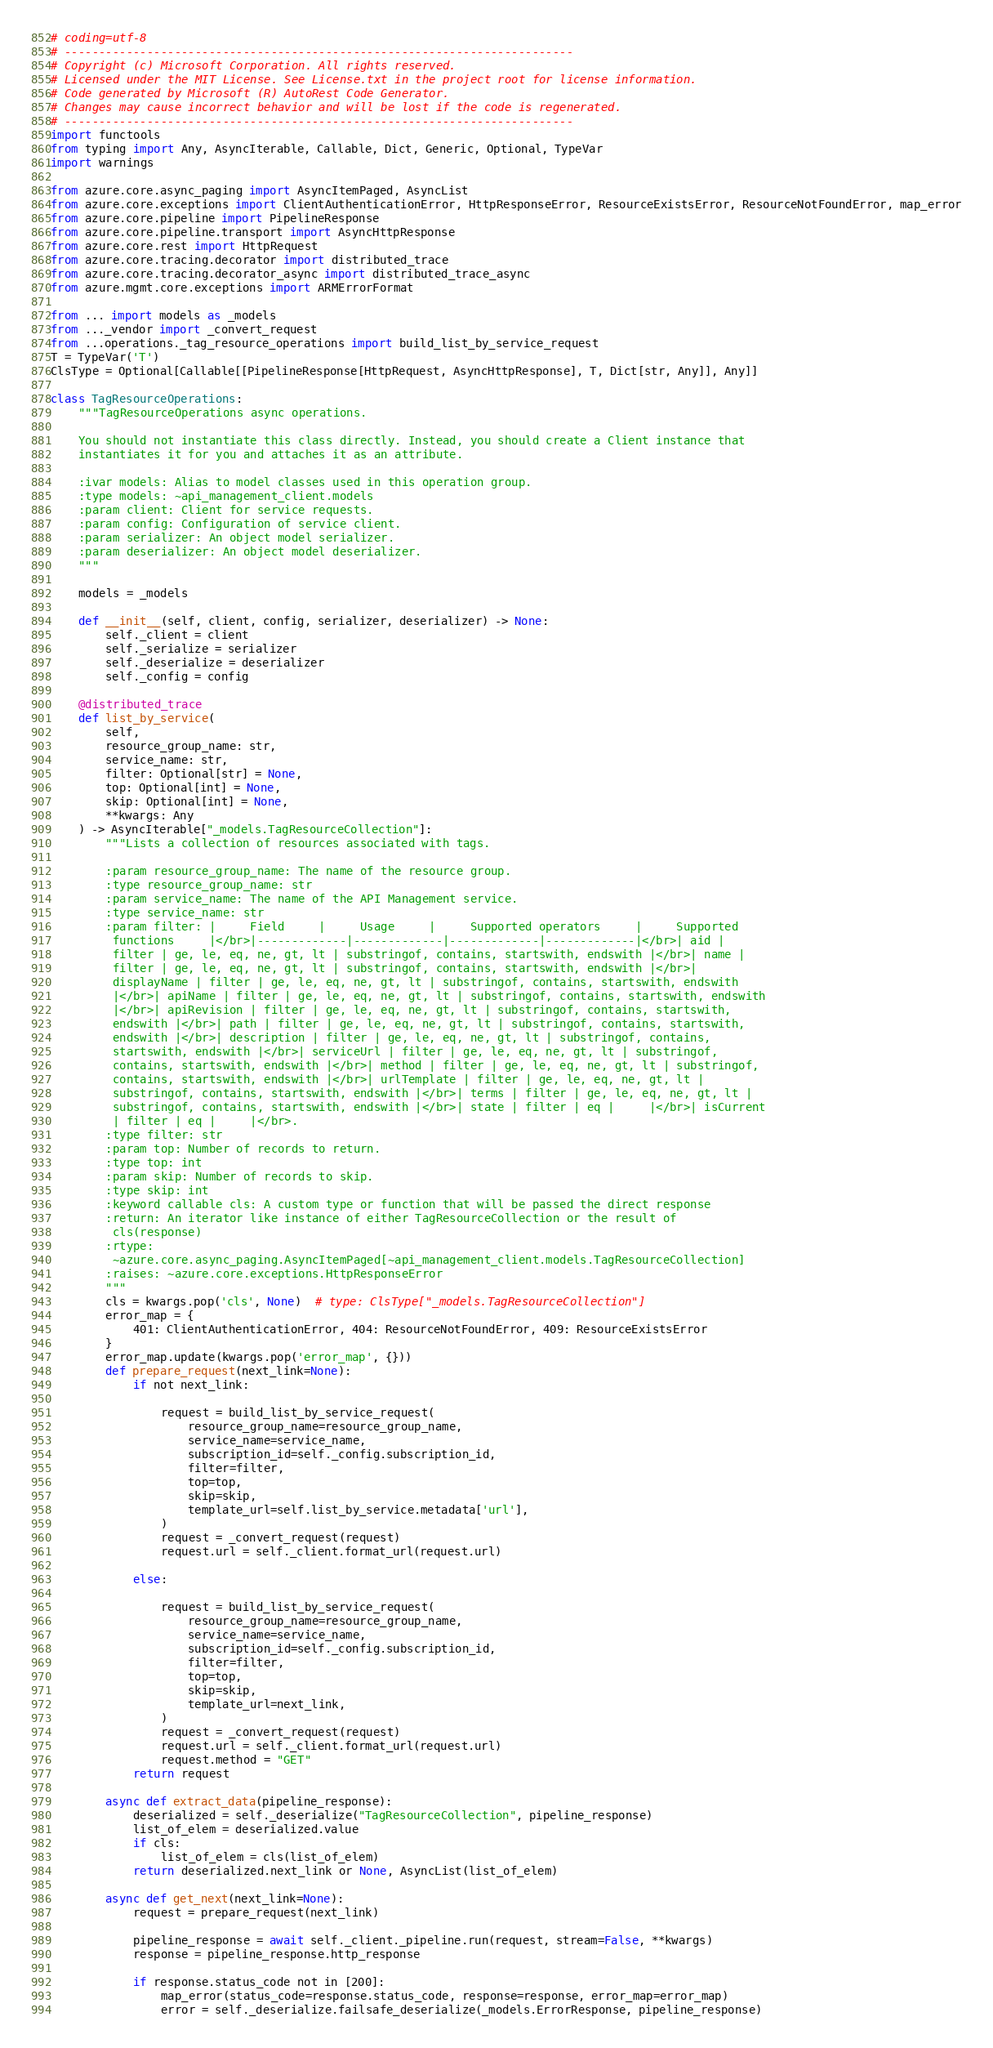Convert code to text. <code><loc_0><loc_0><loc_500><loc_500><_Python_># coding=utf-8
# --------------------------------------------------------------------------
# Copyright (c) Microsoft Corporation. All rights reserved.
# Licensed under the MIT License. See License.txt in the project root for license information.
# Code generated by Microsoft (R) AutoRest Code Generator.
# Changes may cause incorrect behavior and will be lost if the code is regenerated.
# --------------------------------------------------------------------------
import functools
from typing import Any, AsyncIterable, Callable, Dict, Generic, Optional, TypeVar
import warnings

from azure.core.async_paging import AsyncItemPaged, AsyncList
from azure.core.exceptions import ClientAuthenticationError, HttpResponseError, ResourceExistsError, ResourceNotFoundError, map_error
from azure.core.pipeline import PipelineResponse
from azure.core.pipeline.transport import AsyncHttpResponse
from azure.core.rest import HttpRequest
from azure.core.tracing.decorator import distributed_trace
from azure.core.tracing.decorator_async import distributed_trace_async
from azure.mgmt.core.exceptions import ARMErrorFormat

from ... import models as _models
from ..._vendor import _convert_request
from ...operations._tag_resource_operations import build_list_by_service_request
T = TypeVar('T')
ClsType = Optional[Callable[[PipelineResponse[HttpRequest, AsyncHttpResponse], T, Dict[str, Any]], Any]]

class TagResourceOperations:
    """TagResourceOperations async operations.

    You should not instantiate this class directly. Instead, you should create a Client instance that
    instantiates it for you and attaches it as an attribute.

    :ivar models: Alias to model classes used in this operation group.
    :type models: ~api_management_client.models
    :param client: Client for service requests.
    :param config: Configuration of service client.
    :param serializer: An object model serializer.
    :param deserializer: An object model deserializer.
    """

    models = _models

    def __init__(self, client, config, serializer, deserializer) -> None:
        self._client = client
        self._serialize = serializer
        self._deserialize = deserializer
        self._config = config

    @distributed_trace
    def list_by_service(
        self,
        resource_group_name: str,
        service_name: str,
        filter: Optional[str] = None,
        top: Optional[int] = None,
        skip: Optional[int] = None,
        **kwargs: Any
    ) -> AsyncIterable["_models.TagResourceCollection"]:
        """Lists a collection of resources associated with tags.

        :param resource_group_name: The name of the resource group.
        :type resource_group_name: str
        :param service_name: The name of the API Management service.
        :type service_name: str
        :param filter: |     Field     |     Usage     |     Supported operators     |     Supported
         functions     |</br>|-------------|-------------|-------------|-------------|</br>| aid |
         filter | ge, le, eq, ne, gt, lt | substringof, contains, startswith, endswith |</br>| name |
         filter | ge, le, eq, ne, gt, lt | substringof, contains, startswith, endswith |</br>|
         displayName | filter | ge, le, eq, ne, gt, lt | substringof, contains, startswith, endswith
         |</br>| apiName | filter | ge, le, eq, ne, gt, lt | substringof, contains, startswith, endswith
         |</br>| apiRevision | filter | ge, le, eq, ne, gt, lt | substringof, contains, startswith,
         endswith |</br>| path | filter | ge, le, eq, ne, gt, lt | substringof, contains, startswith,
         endswith |</br>| description | filter | ge, le, eq, ne, gt, lt | substringof, contains,
         startswith, endswith |</br>| serviceUrl | filter | ge, le, eq, ne, gt, lt | substringof,
         contains, startswith, endswith |</br>| method | filter | ge, le, eq, ne, gt, lt | substringof,
         contains, startswith, endswith |</br>| urlTemplate | filter | ge, le, eq, ne, gt, lt |
         substringof, contains, startswith, endswith |</br>| terms | filter | ge, le, eq, ne, gt, lt |
         substringof, contains, startswith, endswith |</br>| state | filter | eq |     |</br>| isCurrent
         | filter | eq |     |</br>.
        :type filter: str
        :param top: Number of records to return.
        :type top: int
        :param skip: Number of records to skip.
        :type skip: int
        :keyword callable cls: A custom type or function that will be passed the direct response
        :return: An iterator like instance of either TagResourceCollection or the result of
         cls(response)
        :rtype:
         ~azure.core.async_paging.AsyncItemPaged[~api_management_client.models.TagResourceCollection]
        :raises: ~azure.core.exceptions.HttpResponseError
        """
        cls = kwargs.pop('cls', None)  # type: ClsType["_models.TagResourceCollection"]
        error_map = {
            401: ClientAuthenticationError, 404: ResourceNotFoundError, 409: ResourceExistsError
        }
        error_map.update(kwargs.pop('error_map', {}))
        def prepare_request(next_link=None):
            if not next_link:
                
                request = build_list_by_service_request(
                    resource_group_name=resource_group_name,
                    service_name=service_name,
                    subscription_id=self._config.subscription_id,
                    filter=filter,
                    top=top,
                    skip=skip,
                    template_url=self.list_by_service.metadata['url'],
                )
                request = _convert_request(request)
                request.url = self._client.format_url(request.url)

            else:
                
                request = build_list_by_service_request(
                    resource_group_name=resource_group_name,
                    service_name=service_name,
                    subscription_id=self._config.subscription_id,
                    filter=filter,
                    top=top,
                    skip=skip,
                    template_url=next_link,
                )
                request = _convert_request(request)
                request.url = self._client.format_url(request.url)
                request.method = "GET"
            return request

        async def extract_data(pipeline_response):
            deserialized = self._deserialize("TagResourceCollection", pipeline_response)
            list_of_elem = deserialized.value
            if cls:
                list_of_elem = cls(list_of_elem)
            return deserialized.next_link or None, AsyncList(list_of_elem)

        async def get_next(next_link=None):
            request = prepare_request(next_link)

            pipeline_response = await self._client._pipeline.run(request, stream=False, **kwargs)
            response = pipeline_response.http_response

            if response.status_code not in [200]:
                map_error(status_code=response.status_code, response=response, error_map=error_map)
                error = self._deserialize.failsafe_deserialize(_models.ErrorResponse, pipeline_response)</code> 